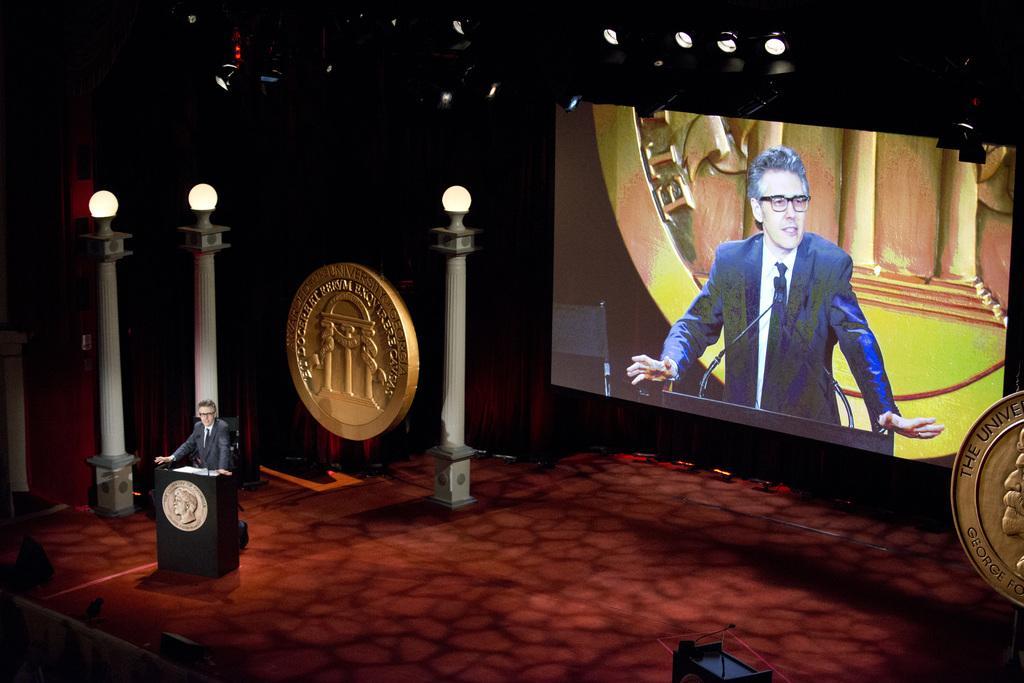Can you describe this image briefly? In this picture I can observe a man standing in front of the podium. On the left side there are three poles to which lamps are fixed. On the right side I can observe a screen. The background is dark. 